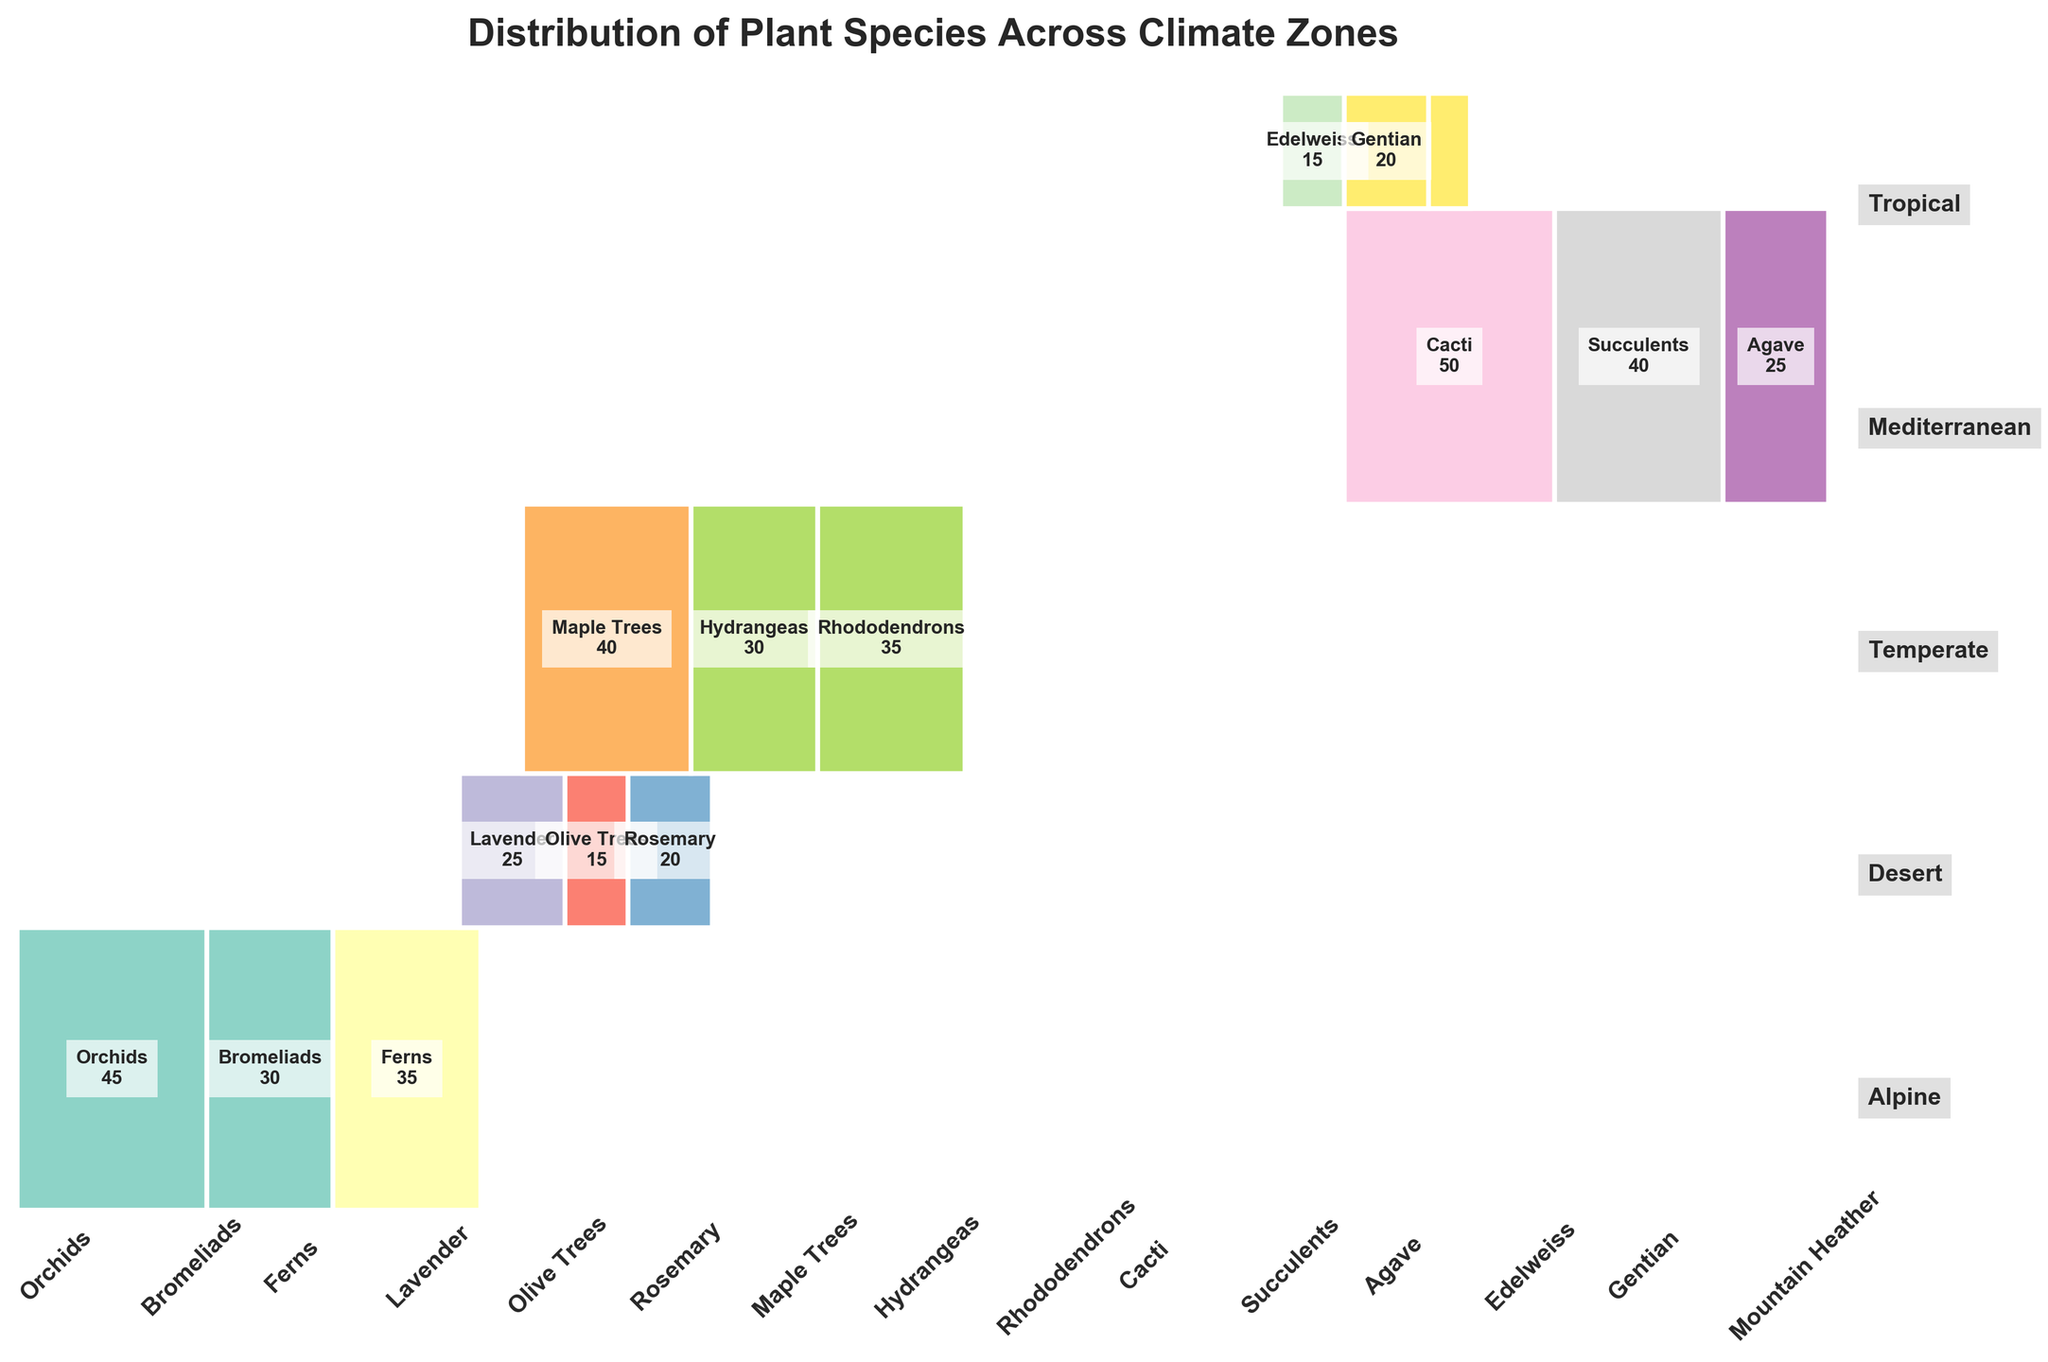What's the title of the figure? The title of the figure could be found at the top center of the plot. It reads: "Distribution of Plant Species Across Climate Zones."
Answer: Distribution of Plant Species Across Climate Zones Which climate zone has the highest count of plant species? Observing the y-axis on the mosaic plot, the height of the rectangles represents the proportion of plant species in each climate zone. The tallest rectangle corresponds to the "Desert" climate zone, indicating it has the highest count.
Answer: Desert How many orchids are there in the tropical zone? In the mosaic plot, locate the rectangle for "Tropical" on the y-axis and "Orchids" on the x-axis. The count appears inside the rectangle, which is "45."
Answer: 45 Which climate zone has the least variety of plant types? Examine the number of distinct rectangles along the x-axis for each climate zone. The "Alpine" climate zone has the least variety, with only three plant types (Edelweiss, Gentian, Mountain Heather).
Answer: Alpine What is the combined count of plant species in the Mediterranean and Temperate zones? Add the individual counts for each plant type in both zones. Mediterranean (Lavender: 25, Olive Trees: 15, Rosemary: 20) totals to 60. Temperate (Maple Trees: 40, Hydrangeas: 30, Rhododendrons: 35) totals to 105. Sum these totals: 60 + 105 = 165.
Answer: 165 Are there more succulents or hydrangeas in the garden? Find the rectangles corresponding to "Succulents" and "Hydrangeas." Succulents in the Desert zone have 40, while Hydrangeas in the Temperate zone have 30. Therefore, there are more succulents.
Answer: Succulents Which plant type has the highest count overall, regardless of climate zone? Observing the width of the rectangles along the x-axis, the plant type with the widest rectangle represents the highest count. "Cacti" in the desert zone have the highest count of 50.
Answer: Cacti Compare the total counts of ferns and rosemary. Which is greater? Locate the rectangles for "Ferns" and "Rosemary." Ferns in the Tropical zone have 35, while Rosemary in the Mediterranean zone has 20. Therefore, Ferns have a greater total count.
Answer: Ferns In which climate zone are orchids found? Turn to the plot and find the section labeled "Orchids" on the x-axis. This is positioned within the "Tropical" climate zone on the y-axis, which means orchids are found in the Tropical zone.
Answer: Tropical What is the proportion of cacti in the entire garden? The proportion can be determined by the size of the rectangle for "Cacti" relative to the entire plot. The count for Cacti is 50. The total count for all plant species is 400. Thus, the proportion is 50/400 = 0.125 or 12.5%.
Answer: 12.5% 